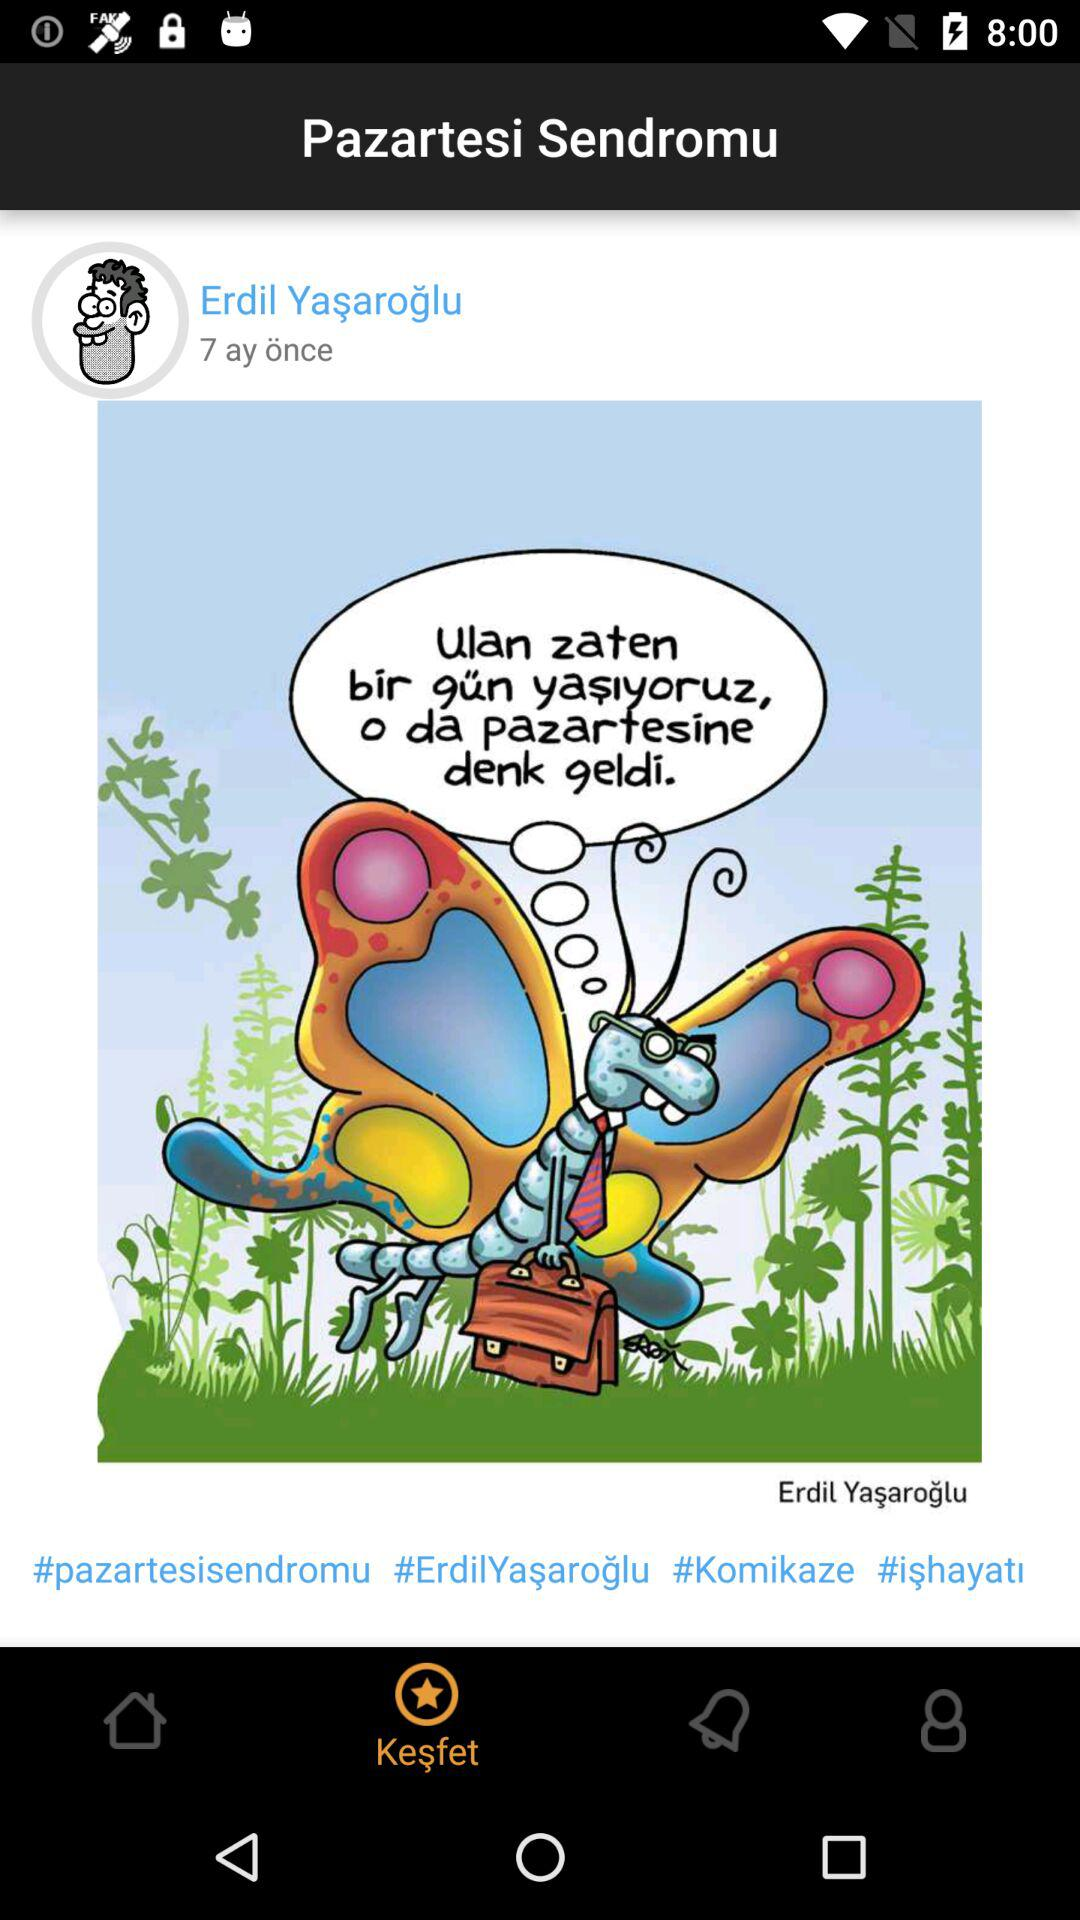How many hashtags are on this post?
Answer the question using a single word or phrase. 4 